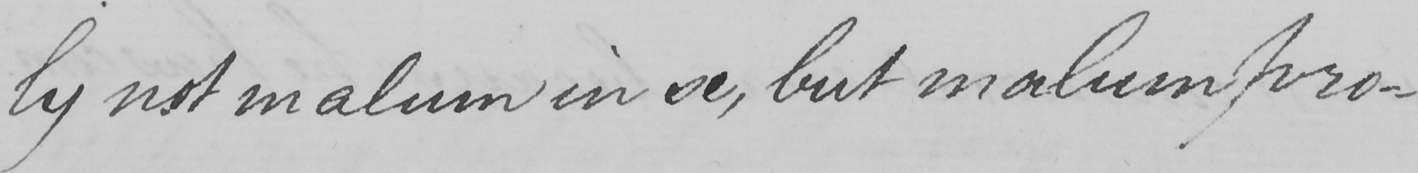Please provide the text content of this handwritten line. ly not malum in se , but malum pro- 